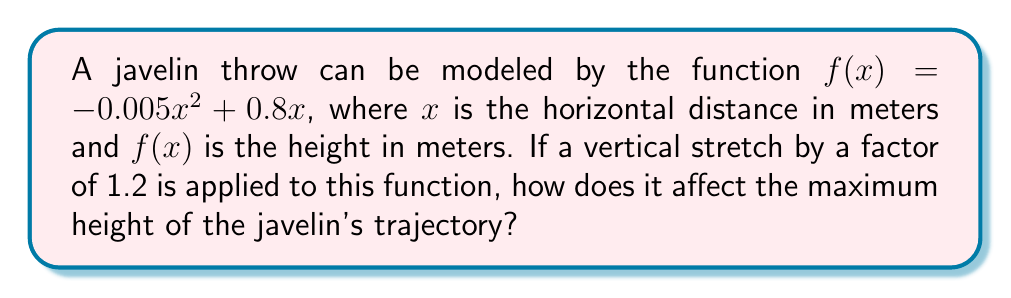Provide a solution to this math problem. Let's approach this step-by-step:

1) The original function is $f(x) = -0.005x^2 + 0.8x$

2) A vertical stretch by a factor of 1.2 is applied. This means we multiply the entire function by 1.2:

   $g(x) = 1.2f(x) = 1.2(-0.005x^2 + 0.8x) = -0.006x^2 + 0.96x$

3) To find the maximum height, we need to find the vertex of this parabola. For a quadratic function in the form $ax^2 + bx + c$, the x-coordinate of the vertex is given by $-b/(2a)$

4) For $g(x) = -0.006x^2 + 0.96x$, we have $a = -0.006$ and $b = 0.96$

5) The x-coordinate of the vertex is:
   $x = -b/(2a) = -0.96 / (2(-0.006)) = 80$ meters

6) To find the maximum height, we substitute this x-value back into $g(x)$:

   $g(80) = -0.006(80)^2 + 0.96(80) = -38.4 + 76.8 = 38.4$ meters

7) The original maximum height can be found similarly:
   
   $f(80) = -0.005(80)^2 + 0.8(80) = -32 + 64 = 32$ meters

8) The difference in maximum height is:
   $38.4 - 32 = 6.4$ meters

Therefore, the vertical stretch increases the maximum height by 6.4 meters, which is exactly 20% of the original maximum height (as expected from a 1.2 vertical stretch).
Answer: The maximum height increases by 6.4 meters. 